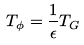Convert formula to latex. <formula><loc_0><loc_0><loc_500><loc_500>T _ { \phi } = \frac { 1 } { \epsilon } T _ { G }</formula> 